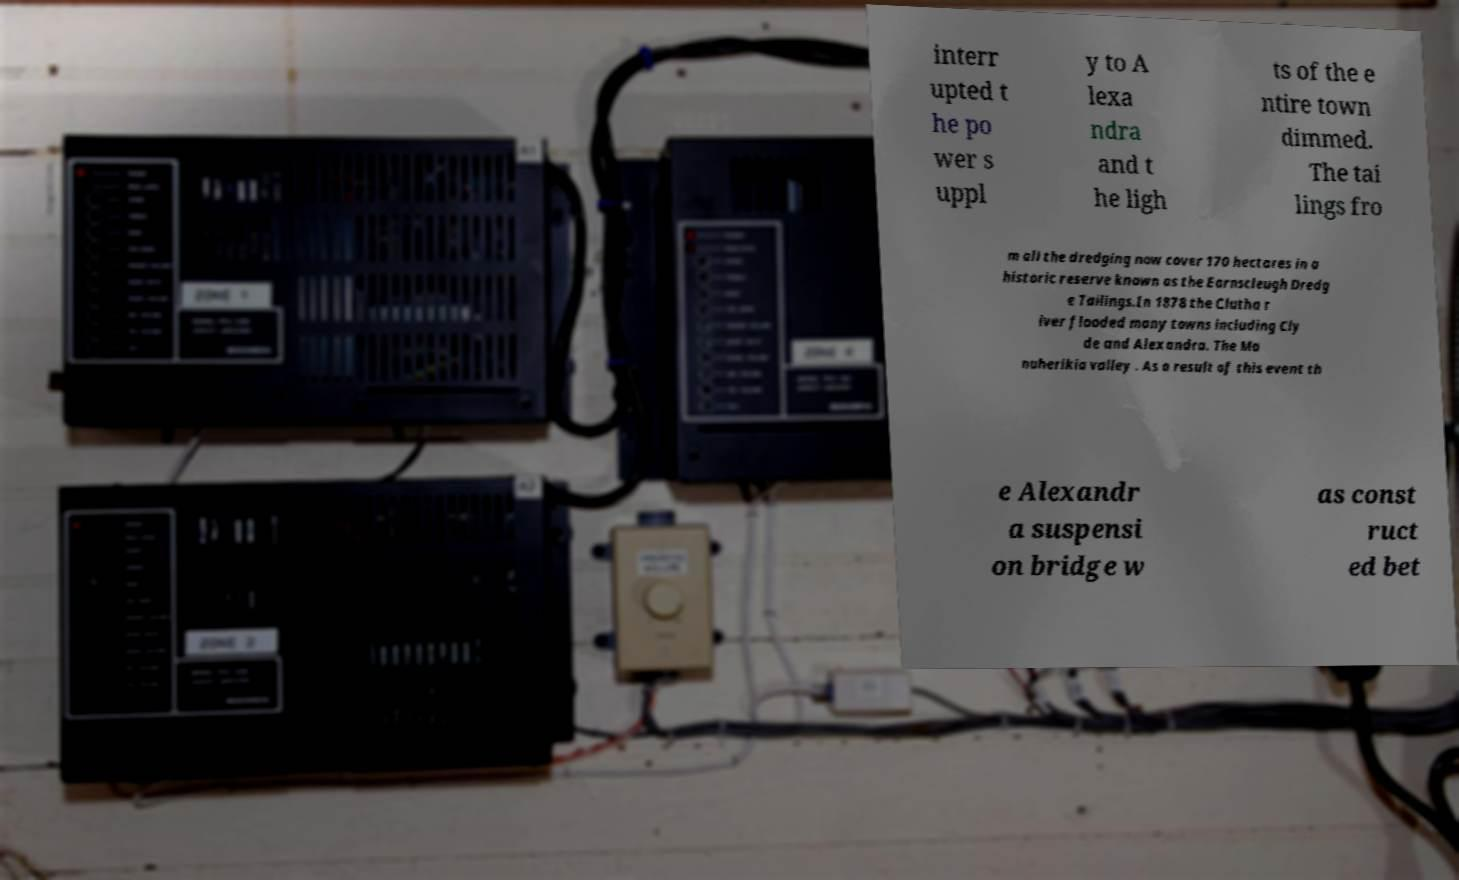Please read and relay the text visible in this image. What does it say? interr upted t he po wer s uppl y to A lexa ndra and t he ligh ts of the e ntire town dimmed. The tai lings fro m all the dredging now cover 170 hectares in a historic reserve known as the Earnscleugh Dredg e Tailings.In 1878 the Clutha r iver flooded many towns including Cly de and Alexandra. The Ma nuherikia valley . As a result of this event th e Alexandr a suspensi on bridge w as const ruct ed bet 